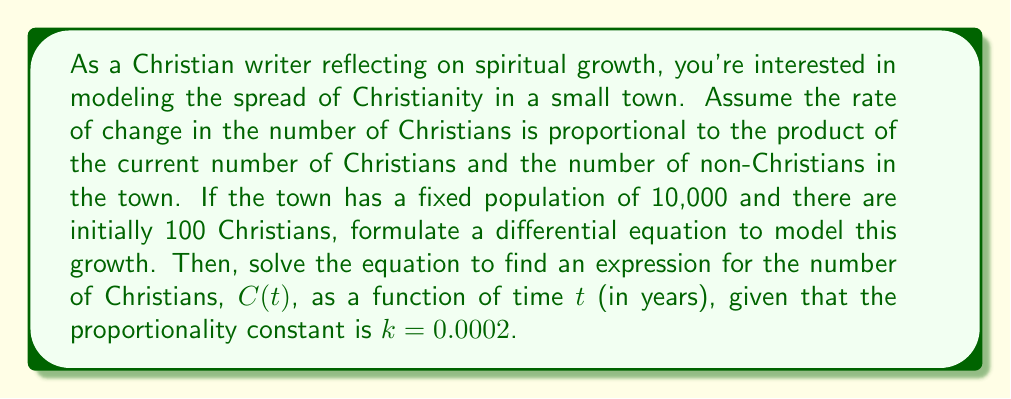Could you help me with this problem? Let's approach this step-by-step:

1) Let $C(t)$ be the number of Christians at time $t$. The total population is 10,000, so the number of non-Christians is $10000 - C(t)$.

2) The rate of change of Christians is proportional to the product of Christians and non-Christians:

   $$\frac{dC}{dt} = kC(t)(10000 - C(t))$$

   where $k = 0.0002$ is the proportionality constant.

3) This is a separable differential equation. Let's rearrange it:

   $$\frac{dC}{C(10000 - C)} = 0.0002 dt$$

4) Integrate both sides:

   $$\int \frac{dC}{C(10000 - C)} = \int 0.0002 dt$$

5) The left side can be integrated using partial fractions:

   $$\frac{1}{10000} \ln|\frac{C}{10000-C}| = 0.0002t + A$$

   where $A$ is a constant of integration.

6) Apply the initial condition: At $t=0$, $C(0) = 100$:

   $$\frac{1}{10000} \ln|\frac{100}{9900}| = A$$

7) Subtract this from the general solution:

   $$\frac{1}{10000} \ln|\frac{C}{10000-C}| - \frac{1}{10000} \ln|\frac{100}{9900}| = 0.0002t$$

8) Simplify:

   $$\ln|\frac{C}{10000-C}| - \ln|\frac{100}{9900}| = 2t$$

9) Take $e$ to the power of both sides:

   $$\frac{C}{10000-C} = \frac{100}{9900} e^{2t}$$

10) Solve for $C$:

    $$C(t) = \frac{1000000e^{2t}}{99 + e^{2t}}$$

This is the solution to the differential equation, representing the number of Christians as a function of time.
Answer: $$C(t) = \frac{1000000e^{2t}}{99 + e^{2t}}$$ 